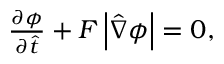<formula> <loc_0><loc_0><loc_500><loc_500>\begin{array} { r } { \frac { \partial \phi } { \partial \hat { t } } + F \left | \hat { \nabla } \phi \right | = 0 , } \end{array}</formula> 